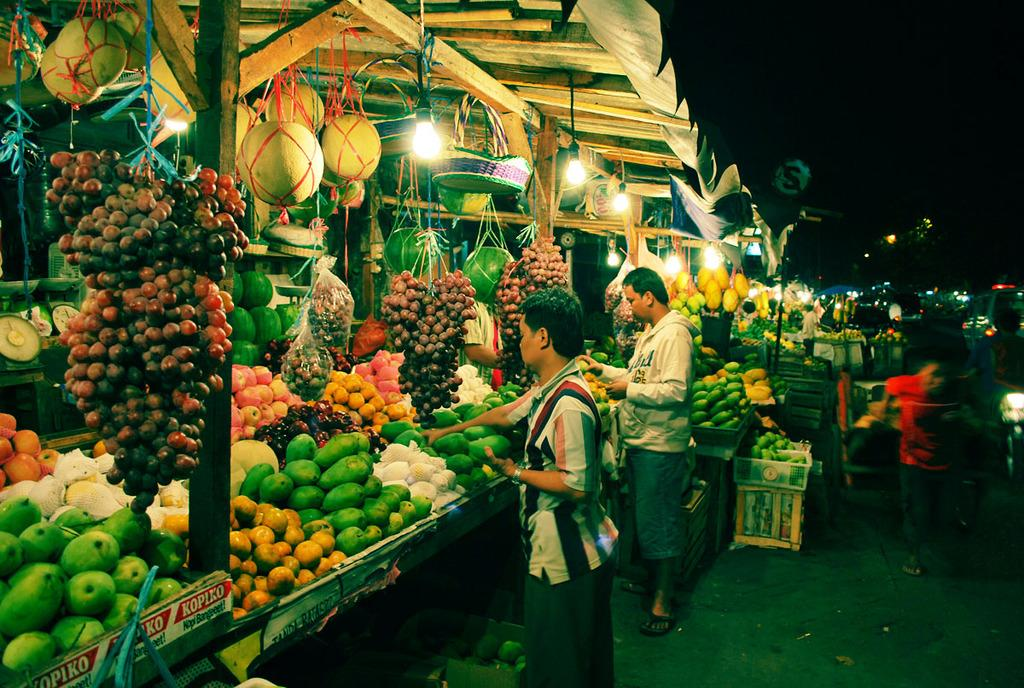What type of establishment is shown in the image? There is a fruit market in the image. What can be seen in the fruit market? There are different fruits visible in the image, and there are people standing and holding fruits. What type of lighting is present in the image? There are lights visible in the image. What type of structure is present in the fruit market? There is a wooden shed in the image. What reward is being given to the person who performs the magic trick in the image? There is no magic trick or reward present in the image; it is a fruit market with people holding fruits. 